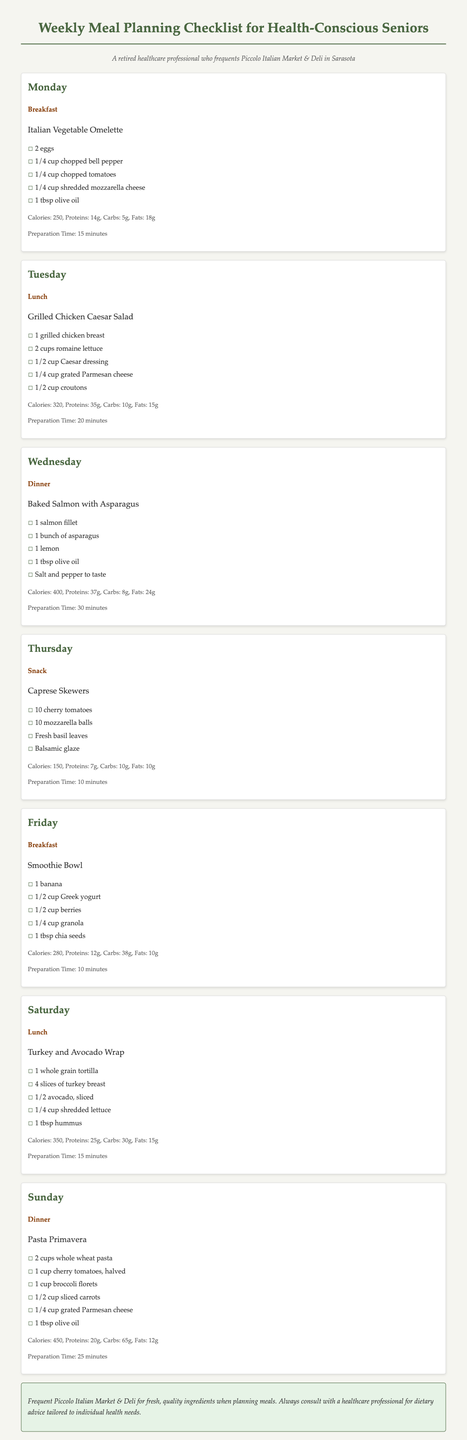What is the recipe for Monday breakfast? The recipe for Monday breakfast is Italian Vegetable Omelette.
Answer: Italian Vegetable Omelette How many calories are in the Baked Salmon with Asparagus? The document states that Baked Salmon with Asparagus has 400 calories.
Answer: 400 What is the preparation time for the Smoothie Bowl? According to the document, the preparation time for the Smoothie Bowl is 10 minutes.
Answer: 10 minutes Which meal is served on Thursday? The meal served on Thursday is a snack called Caprese Skewers.
Answer: Snack What ingredients are in the Pasta Primavera? The ingredients for Pasta Primavera include whole wheat pasta, cherry tomatoes, broccoli florets, sliced carrots, grated Parmesan cheese, and olive oil.
Answer: Whole wheat pasta, cherry tomatoes, broccoli florets, sliced carrots, grated Parmesan cheese, olive oil What is the total preparation time for the meals on Monday and Tuesday? To find the total preparation time, add 15 minutes for Monday and 20 minutes for Tuesday, resulting in 35 minutes total.
Answer: 35 minutes How many grams of protein are in the Turkey and Avocado Wrap? The protein content in the Turkey and Avocado Wrap is 25 grams.
Answer: 25g What type of checklist is this document? This document is a weekly meal planning checklist for health-conscious seniors.
Answer: Weekly Meal Planning Checklist for Health-Conscious Seniors 